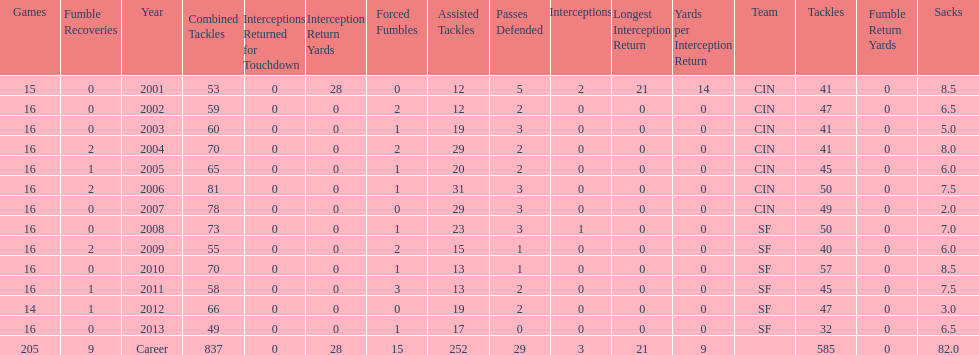What is the only season he has fewer than three sacks? 2007. 